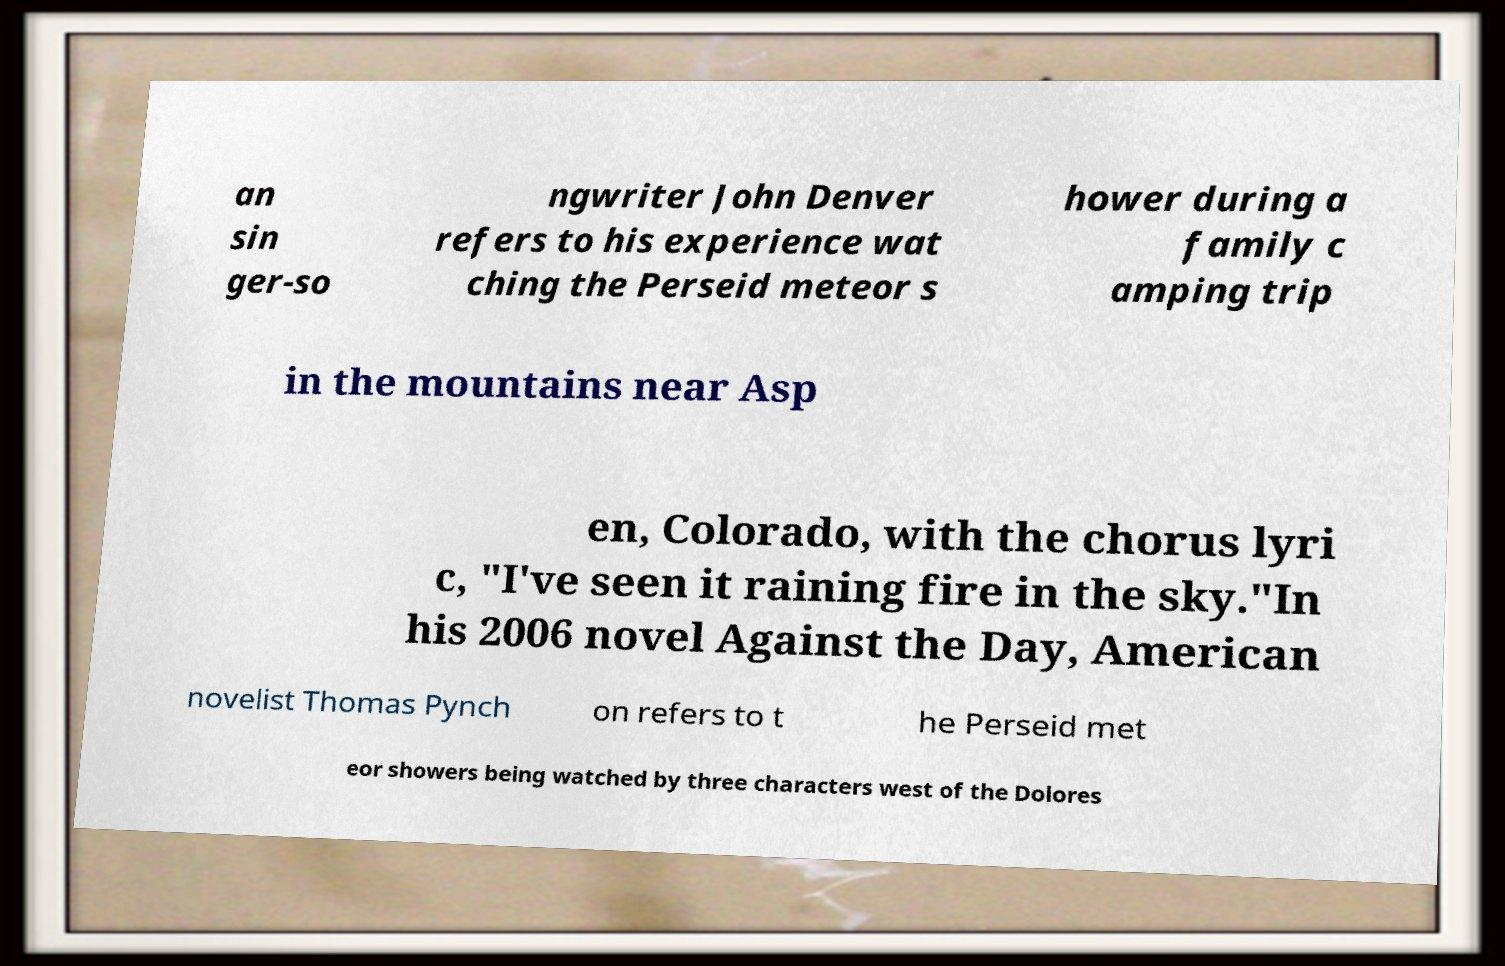Please read and relay the text visible in this image. What does it say? an sin ger-so ngwriter John Denver refers to his experience wat ching the Perseid meteor s hower during a family c amping trip in the mountains near Asp en, Colorado, with the chorus lyri c, "I've seen it raining fire in the sky."In his 2006 novel Against the Day, American novelist Thomas Pynch on refers to t he Perseid met eor showers being watched by three characters west of the Dolores 